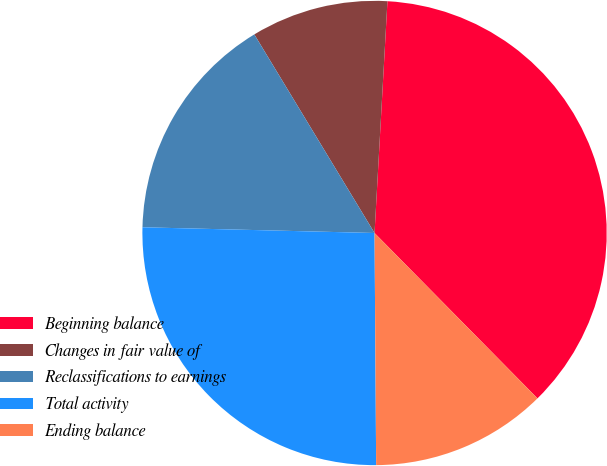<chart> <loc_0><loc_0><loc_500><loc_500><pie_chart><fcel>Beginning balance<fcel>Changes in fair value of<fcel>Reclassifications to earnings<fcel>Total activity<fcel>Ending balance<nl><fcel>36.73%<fcel>9.55%<fcel>15.94%<fcel>25.5%<fcel>12.27%<nl></chart> 